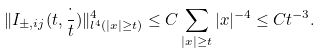Convert formula to latex. <formula><loc_0><loc_0><loc_500><loc_500>\| I _ { \pm , i j } ( t , \frac { \cdot } { t } ) \| _ { l ^ { 4 } ( | x | \geq t ) } ^ { 4 } \leq C \sum _ { | x | \geq t } | x | ^ { - 4 } \leq C t ^ { - 3 } .</formula> 